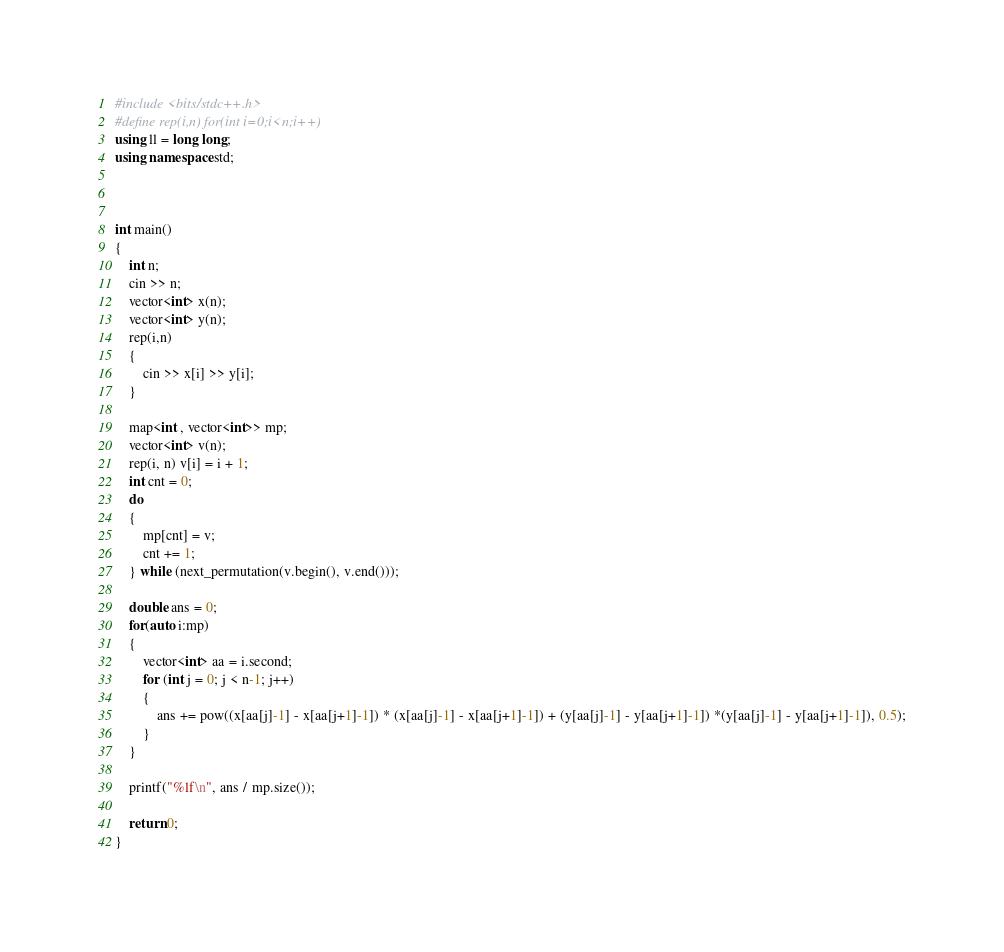Convert code to text. <code><loc_0><loc_0><loc_500><loc_500><_C++_>#include <bits/stdc++.h> 
#define rep(i,n) for(int i=0;i<n;i++)
using ll = long long;
using namespace std;



int main() 
{
    int n;
    cin >> n;
    vector<int> x(n);
    vector<int> y(n);
    rep(i,n)
    {
        cin >> x[i] >> y[i];
    }

    map<int , vector<int>> mp;
    vector<int> v(n);
    rep(i, n) v[i] = i + 1;
    int cnt = 0;
    do
    {
        mp[cnt] = v;
        cnt += 1;
    } while (next_permutation(v.begin(), v.end()));

    double ans = 0;
    for(auto i:mp)
    {
        vector<int> aa = i.second;
        for (int j = 0; j < n-1; j++)
        {
            ans += pow((x[aa[j]-1] - x[aa[j+1]-1]) * (x[aa[j]-1] - x[aa[j+1]-1]) + (y[aa[j]-1] - y[aa[j+1]-1]) *(y[aa[j]-1] - y[aa[j+1]-1]), 0.5);
        }
    }

    printf("%lf\n", ans / mp.size());

    return 0;
}</code> 